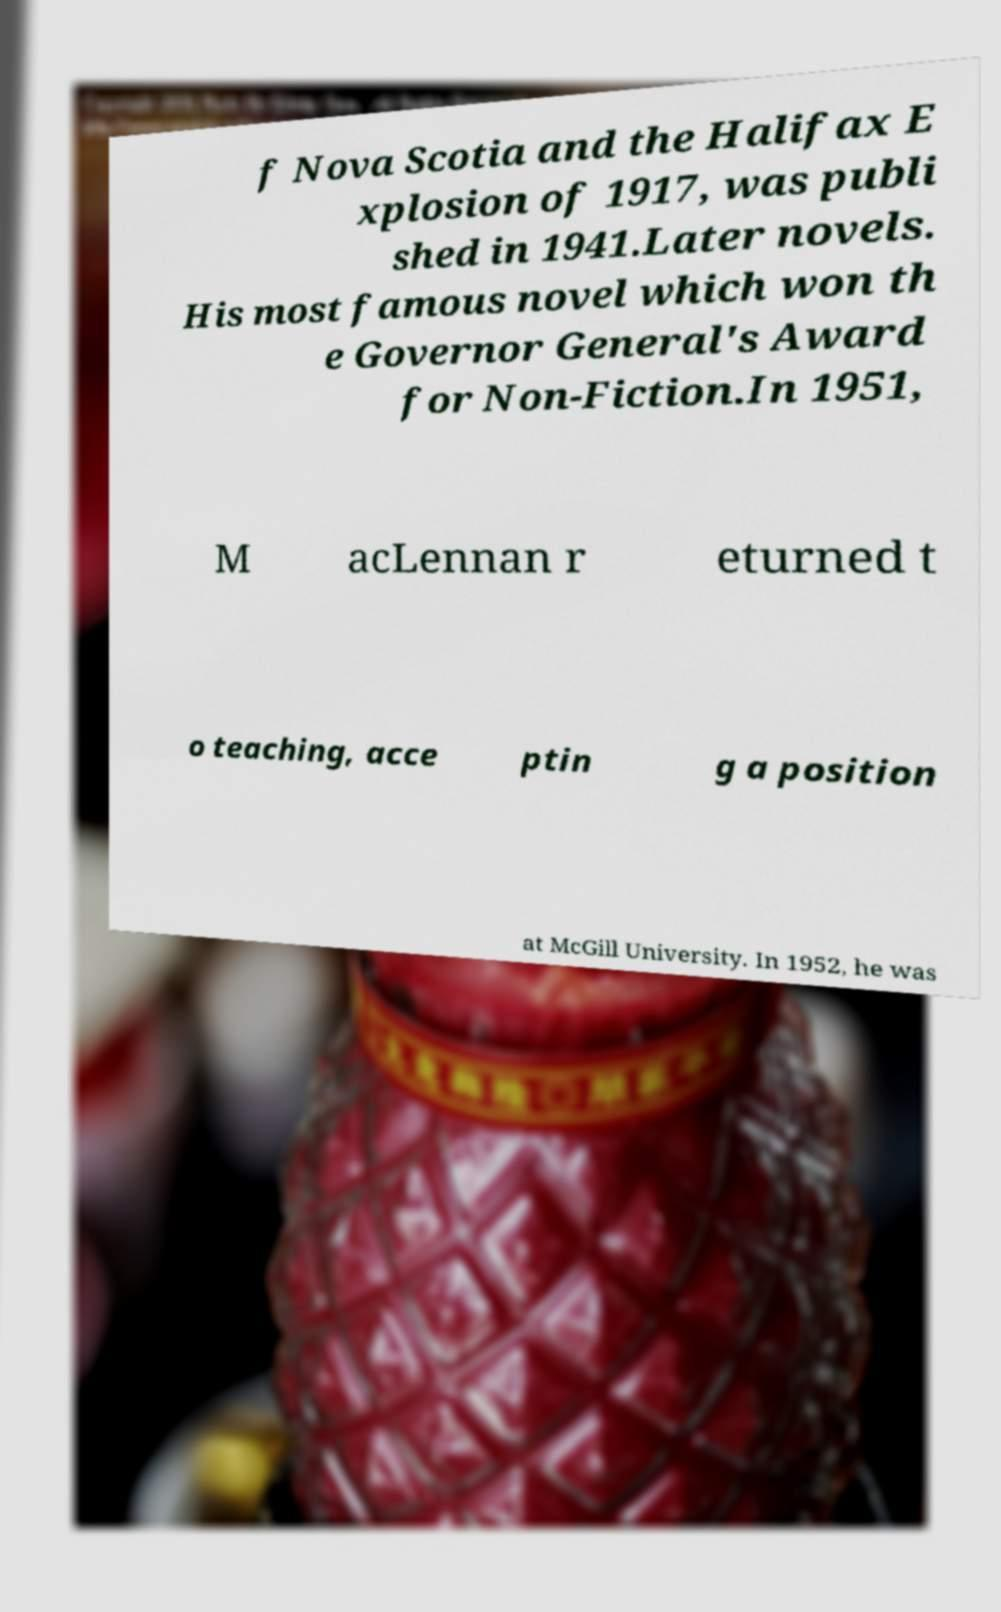For documentation purposes, I need the text within this image transcribed. Could you provide that? f Nova Scotia and the Halifax E xplosion of 1917, was publi shed in 1941.Later novels. His most famous novel which won th e Governor General's Award for Non-Fiction.In 1951, M acLennan r eturned t o teaching, acce ptin g a position at McGill University. In 1952, he was 